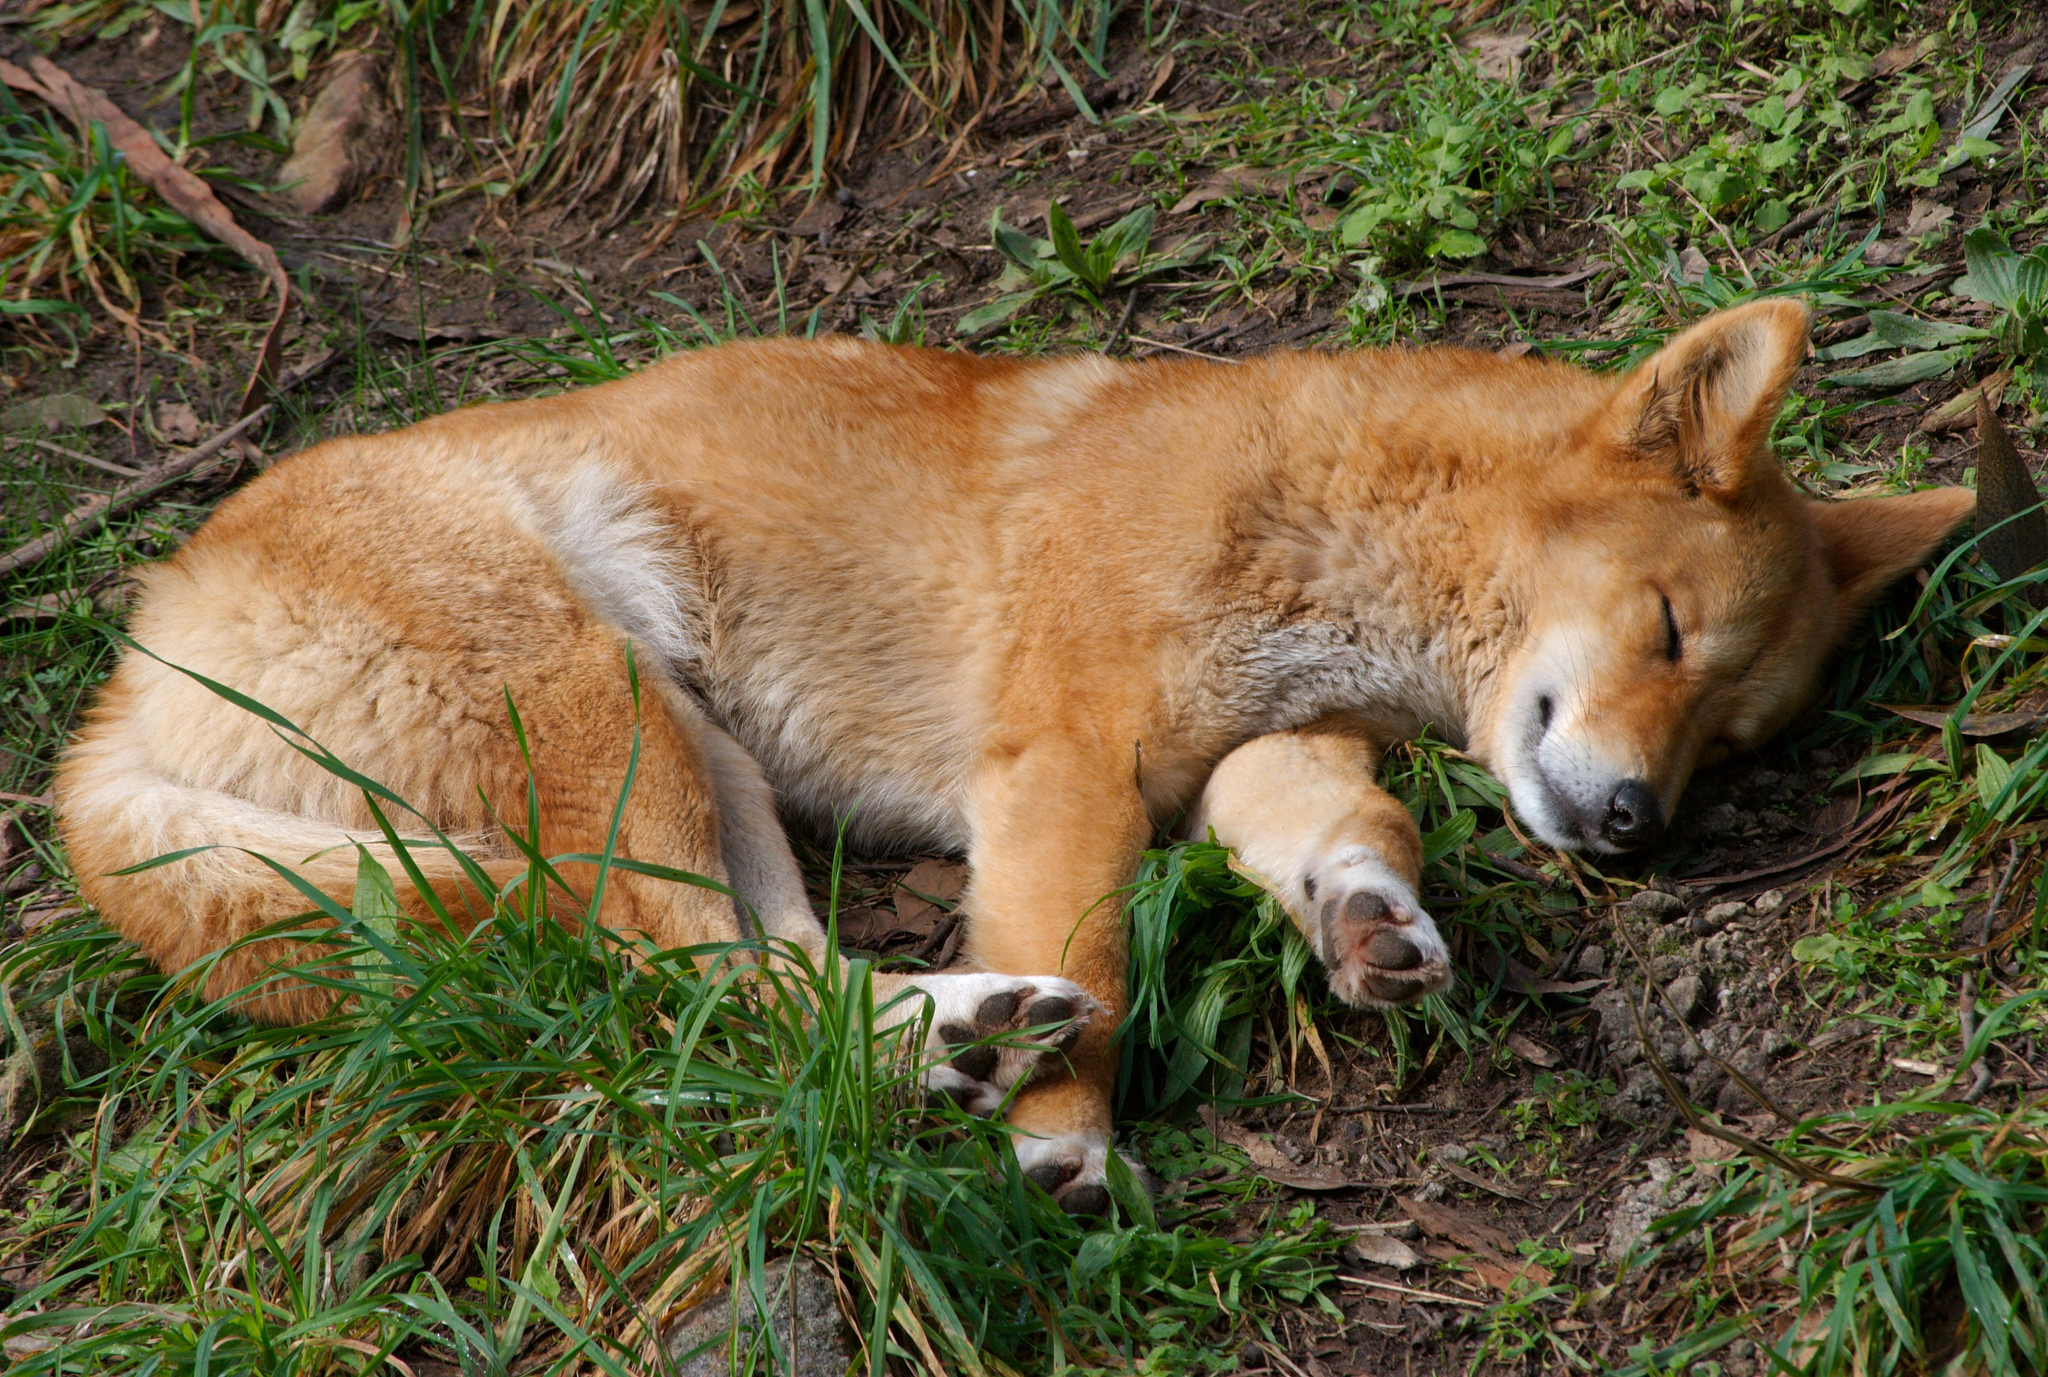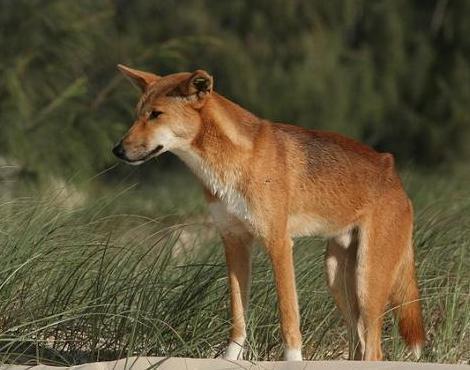The first image is the image on the left, the second image is the image on the right. Considering the images on both sides, is "The dog in the image on the left has its eyes closed." valid? Answer yes or no. Yes. The first image is the image on the left, the second image is the image on the right. Considering the images on both sides, is "The dog on the left is sleepy-looking." valid? Answer yes or no. Yes. 